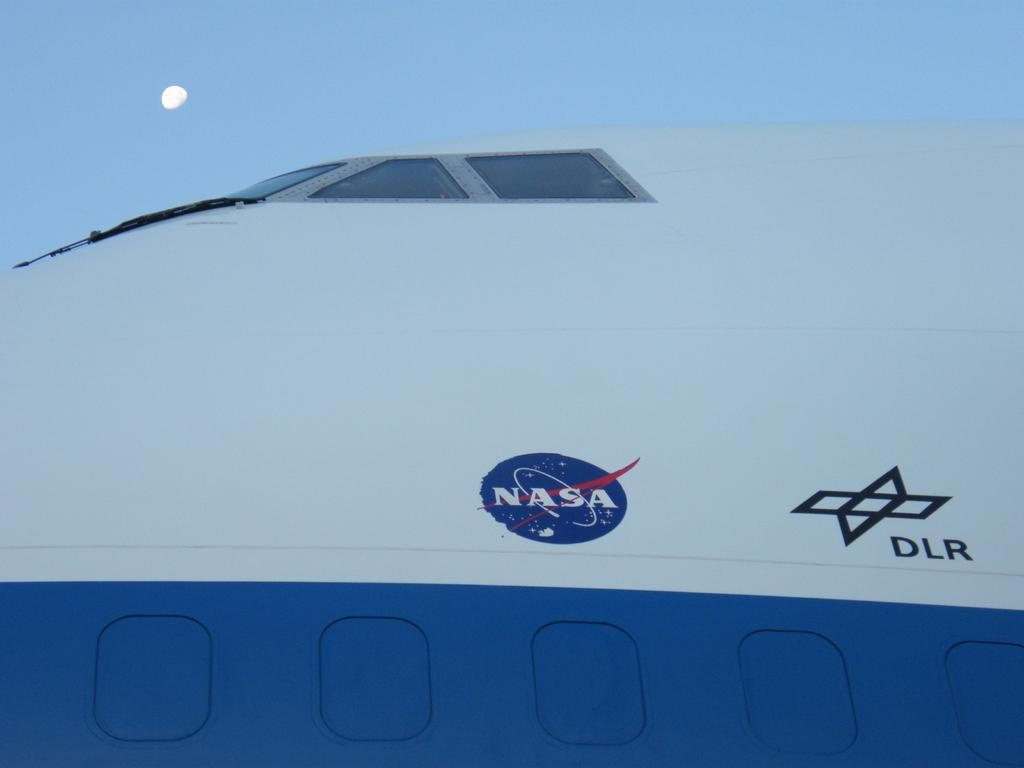<image>
Share a concise interpretation of the image provided. A closeup of a NASA ship that is white and blue. 